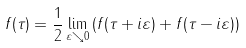<formula> <loc_0><loc_0><loc_500><loc_500>f ( \tau ) = \frac { 1 } { 2 } \lim _ { \varepsilon \searrow 0 } \left ( f ( \tau + i \varepsilon ) + f ( \tau - i \varepsilon ) \right )</formula> 